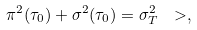Convert formula to latex. <formula><loc_0><loc_0><loc_500><loc_500>\pi ^ { 2 } ( \tau _ { 0 } ) + \sigma ^ { 2 } ( \tau _ { 0 } ) = \sigma ^ { 2 } _ { T } \ > ,</formula> 